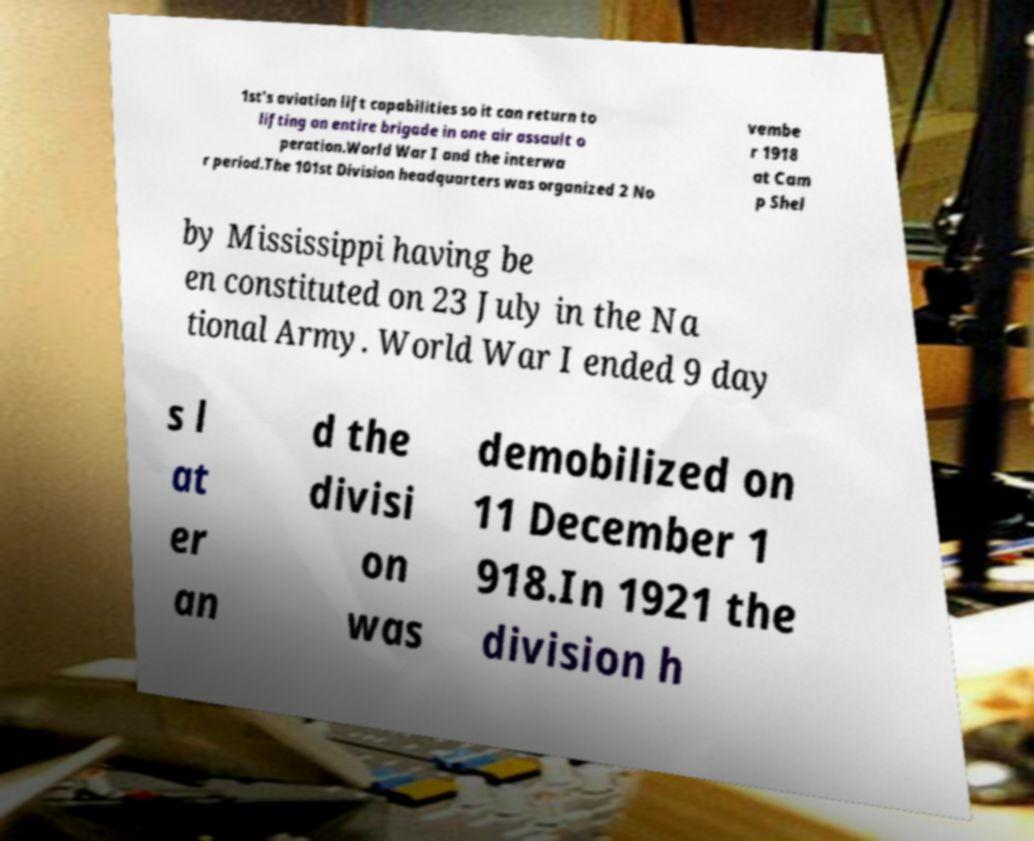Could you extract and type out the text from this image? 1st's aviation lift capabilities so it can return to lifting an entire brigade in one air assault o peration.World War I and the interwa r period.The 101st Division headquarters was organized 2 No vembe r 1918 at Cam p Shel by Mississippi having be en constituted on 23 July in the Na tional Army. World War I ended 9 day s l at er an d the divisi on was demobilized on 11 December 1 918.In 1921 the division h 